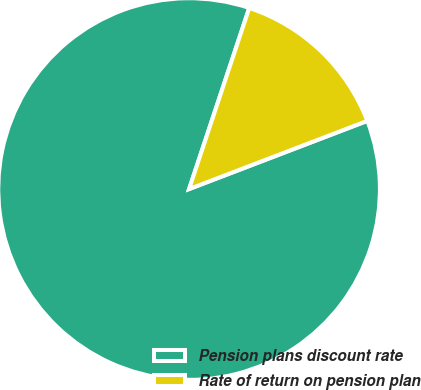<chart> <loc_0><loc_0><loc_500><loc_500><pie_chart><fcel>Pension plans discount rate<fcel>Rate of return on pension plan<nl><fcel>85.92%<fcel>14.08%<nl></chart> 